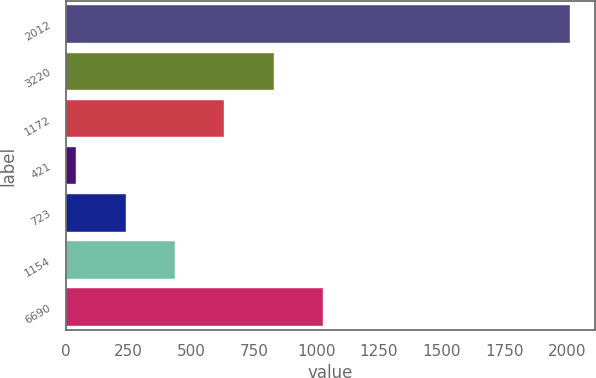<chart> <loc_0><loc_0><loc_500><loc_500><bar_chart><fcel>2012<fcel>3220<fcel>1172<fcel>421<fcel>723<fcel>1154<fcel>6690<nl><fcel>2011<fcel>829.18<fcel>632.21<fcel>41.3<fcel>238.27<fcel>435.24<fcel>1026.15<nl></chart> 